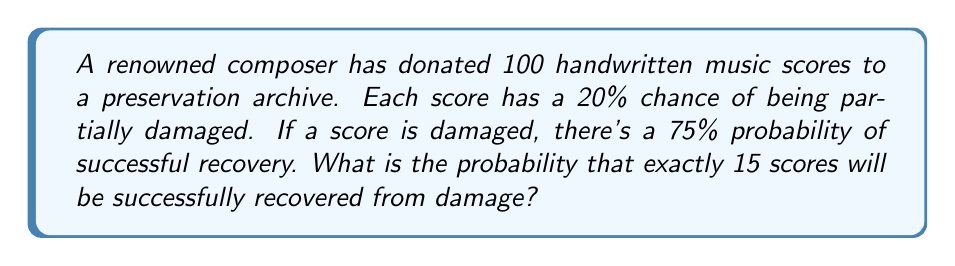Teach me how to tackle this problem. Let's approach this step-by-step:

1) First, we need to calculate the probability of a score being damaged and then successfully recovered:
   $P(\text{damaged and recovered}) = P(\text{damaged}) \times P(\text{recovered | damaged})$
   $= 0.20 \times 0.75 = 0.15$

2) The probability of a score not needing recovery (either undamaged or damaged but not recovered):
   $P(\text{not recovered}) = 1 - 0.15 = 0.85$

3) This scenario follows a binomial distribution with:
   $n = 100$ (total number of scores)
   $p = 0.15$ (probability of success for each trial)
   $k = 15$ (number of successes we're interested in)

4) The probability mass function for a binomial distribution is:

   $$P(X = k) = \binom{n}{k} p^k (1-p)^{n-k}$$

5) Substituting our values:

   $$P(X = 15) = \binom{100}{15} (0.15)^{15} (0.85)^{85}$$

6) Calculate the binomial coefficient:
   
   $$\binom{100}{15} = \frac{100!}{15!(100-15)!} = \frac{100!}{15!85!} \approx 2.5351 \times 10^{17}$$

7) Now, let's calculate the full probability:

   $$P(X = 15) \approx (2.5351 \times 10^{17}) \times (0.15)^{15} \times (0.85)^{85}$$
   
   $$\approx (2.5351 \times 10^{17}) \times (5.7665 \times 10^{-13}) \times (1.0351 \times 10^{-8})$$
   
   $$\approx 0.0151$$

Therefore, the probability of exactly 15 scores being successfully recovered from damage is approximately 0.0151 or 1.51%.
Answer: 0.0151 